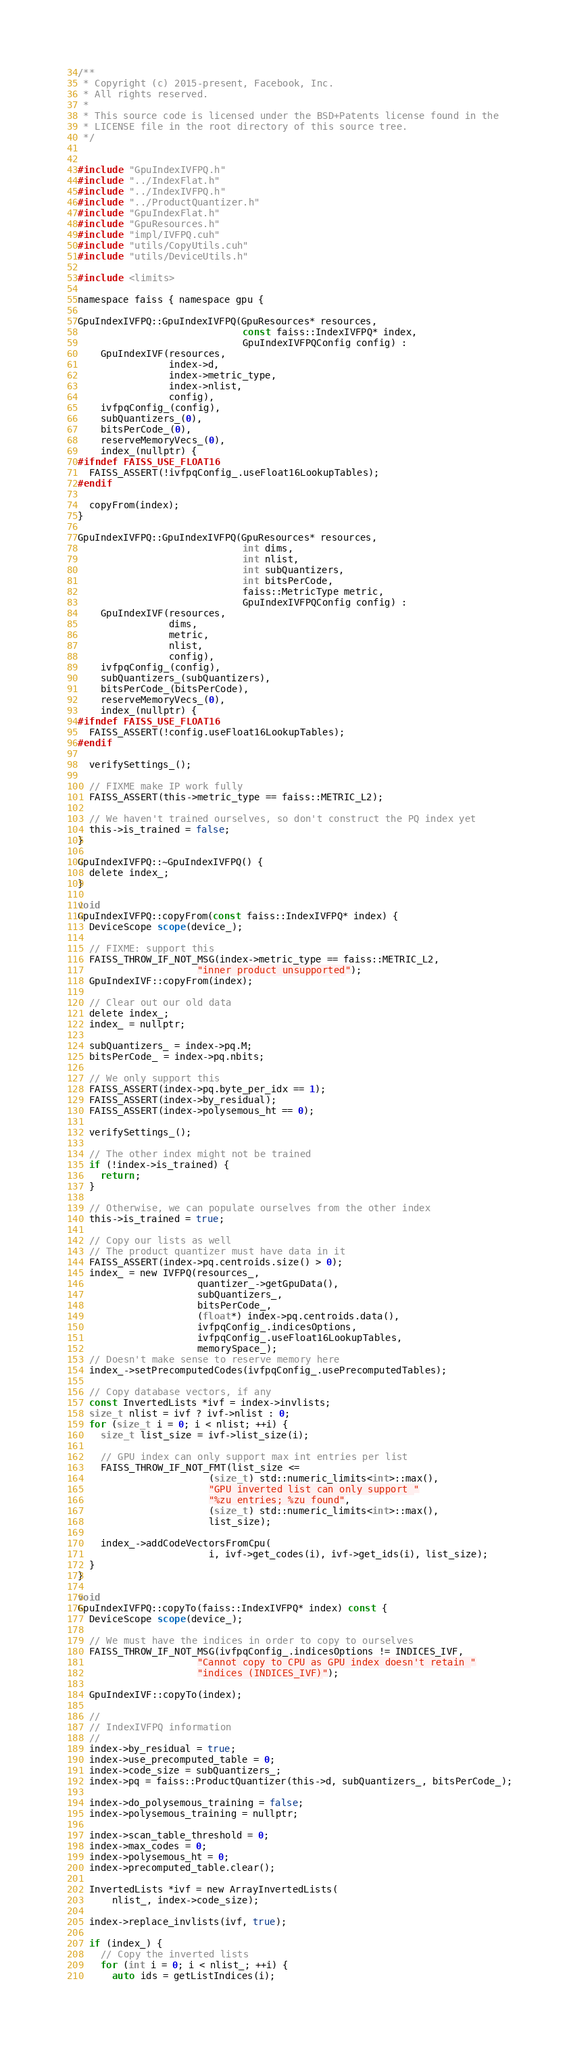Convert code to text. <code><loc_0><loc_0><loc_500><loc_500><_Cuda_>/**
 * Copyright (c) 2015-present, Facebook, Inc.
 * All rights reserved.
 *
 * This source code is licensed under the BSD+Patents license found in the
 * LICENSE file in the root directory of this source tree.
 */


#include "GpuIndexIVFPQ.h"
#include "../IndexFlat.h"
#include "../IndexIVFPQ.h"
#include "../ProductQuantizer.h"
#include "GpuIndexFlat.h"
#include "GpuResources.h"
#include "impl/IVFPQ.cuh"
#include "utils/CopyUtils.cuh"
#include "utils/DeviceUtils.h"

#include <limits>

namespace faiss { namespace gpu {

GpuIndexIVFPQ::GpuIndexIVFPQ(GpuResources* resources,
                             const faiss::IndexIVFPQ* index,
                             GpuIndexIVFPQConfig config) :
    GpuIndexIVF(resources,
                index->d,
                index->metric_type,
                index->nlist,
                config),
    ivfpqConfig_(config),
    subQuantizers_(0),
    bitsPerCode_(0),
    reserveMemoryVecs_(0),
    index_(nullptr) {
#ifndef FAISS_USE_FLOAT16
  FAISS_ASSERT(!ivfpqConfig_.useFloat16LookupTables);
#endif

  copyFrom(index);
}

GpuIndexIVFPQ::GpuIndexIVFPQ(GpuResources* resources,
                             int dims,
                             int nlist,
                             int subQuantizers,
                             int bitsPerCode,
                             faiss::MetricType metric,
                             GpuIndexIVFPQConfig config) :
    GpuIndexIVF(resources,
                dims,
                metric,
                nlist,
                config),
    ivfpqConfig_(config),
    subQuantizers_(subQuantizers),
    bitsPerCode_(bitsPerCode),
    reserveMemoryVecs_(0),
    index_(nullptr) {
#ifndef FAISS_USE_FLOAT16
  FAISS_ASSERT(!config.useFloat16LookupTables);
#endif

  verifySettings_();

  // FIXME make IP work fully
  FAISS_ASSERT(this->metric_type == faiss::METRIC_L2);

  // We haven't trained ourselves, so don't construct the PQ index yet
  this->is_trained = false;
}

GpuIndexIVFPQ::~GpuIndexIVFPQ() {
  delete index_;
}

void
GpuIndexIVFPQ::copyFrom(const faiss::IndexIVFPQ* index) {
  DeviceScope scope(device_);

  // FIXME: support this
  FAISS_THROW_IF_NOT_MSG(index->metric_type == faiss::METRIC_L2,
                     "inner product unsupported");
  GpuIndexIVF::copyFrom(index);

  // Clear out our old data
  delete index_;
  index_ = nullptr;

  subQuantizers_ = index->pq.M;
  bitsPerCode_ = index->pq.nbits;

  // We only support this
  FAISS_ASSERT(index->pq.byte_per_idx == 1);
  FAISS_ASSERT(index->by_residual);
  FAISS_ASSERT(index->polysemous_ht == 0);

  verifySettings_();

  // The other index might not be trained
  if (!index->is_trained) {
    return;
  }

  // Otherwise, we can populate ourselves from the other index
  this->is_trained = true;

  // Copy our lists as well
  // The product quantizer must have data in it
  FAISS_ASSERT(index->pq.centroids.size() > 0);
  index_ = new IVFPQ(resources_,
                     quantizer_->getGpuData(),
                     subQuantizers_,
                     bitsPerCode_,
                     (float*) index->pq.centroids.data(),
                     ivfpqConfig_.indicesOptions,
                     ivfpqConfig_.useFloat16LookupTables,
                     memorySpace_);
  // Doesn't make sense to reserve memory here
  index_->setPrecomputedCodes(ivfpqConfig_.usePrecomputedTables);

  // Copy database vectors, if any
  const InvertedLists *ivf = index->invlists;
  size_t nlist = ivf ? ivf->nlist : 0;
  for (size_t i = 0; i < nlist; ++i) {
    size_t list_size = ivf->list_size(i);

    // GPU index can only support max int entries per list
    FAISS_THROW_IF_NOT_FMT(list_size <=
                       (size_t) std::numeric_limits<int>::max(),
                       "GPU inverted list can only support "
                       "%zu entries; %zu found",
                       (size_t) std::numeric_limits<int>::max(),
                       list_size);

    index_->addCodeVectorsFromCpu(
                       i, ivf->get_codes(i), ivf->get_ids(i), list_size);
  }
}

void
GpuIndexIVFPQ::copyTo(faiss::IndexIVFPQ* index) const {
  DeviceScope scope(device_);

  // We must have the indices in order to copy to ourselves
  FAISS_THROW_IF_NOT_MSG(ivfpqConfig_.indicesOptions != INDICES_IVF,
                     "Cannot copy to CPU as GPU index doesn't retain "
                     "indices (INDICES_IVF)");

  GpuIndexIVF::copyTo(index);

  //
  // IndexIVFPQ information
  //
  index->by_residual = true;
  index->use_precomputed_table = 0;
  index->code_size = subQuantizers_;
  index->pq = faiss::ProductQuantizer(this->d, subQuantizers_, bitsPerCode_);

  index->do_polysemous_training = false;
  index->polysemous_training = nullptr;

  index->scan_table_threshold = 0;
  index->max_codes = 0;
  index->polysemous_ht = 0;
  index->precomputed_table.clear();

  InvertedLists *ivf = new ArrayInvertedLists(
      nlist_, index->code_size);

  index->replace_invlists(ivf, true);

  if (index_) {
    // Copy the inverted lists
    for (int i = 0; i < nlist_; ++i) {
      auto ids = getListIndices(i);</code> 